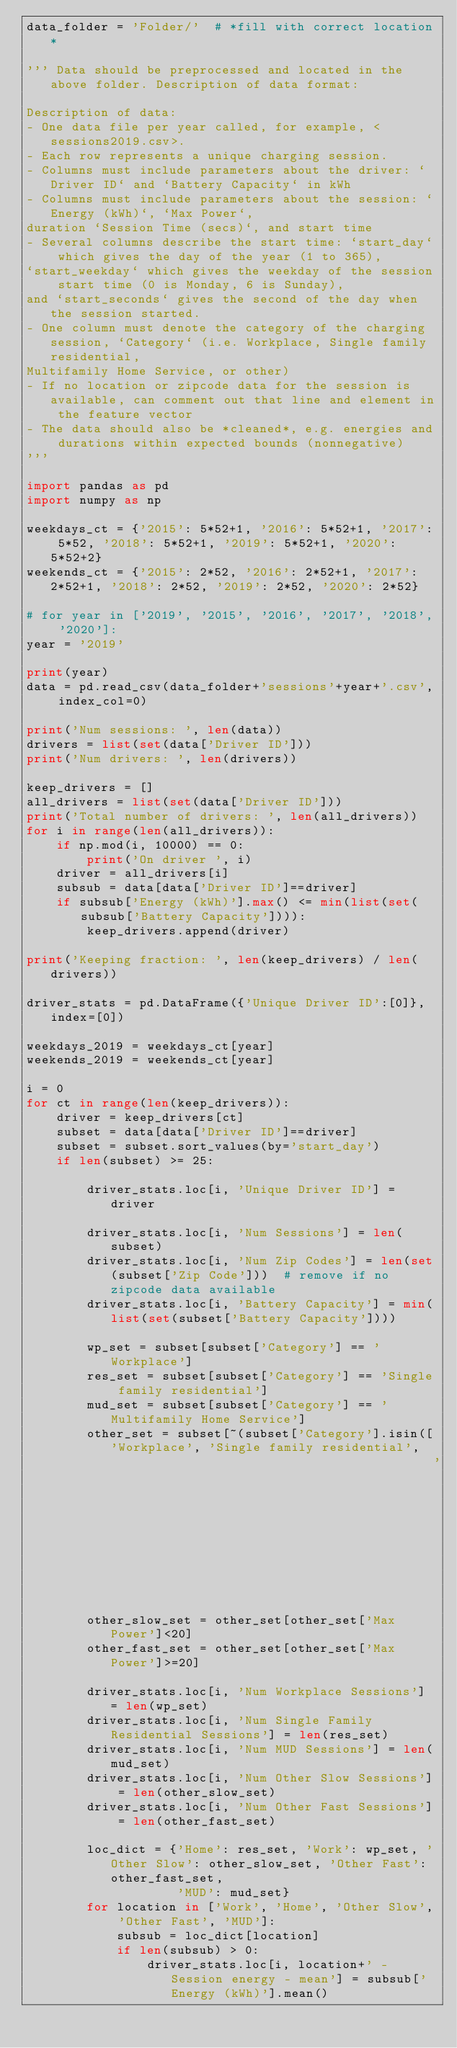Convert code to text. <code><loc_0><loc_0><loc_500><loc_500><_Python_>data_folder = 'Folder/'  # *fill with correct location*

''' Data should be preprocessed and located in the above folder. Description of data format:

Description of data: 
- One data file per year called, for example, <sessions2019.csv>. 
- Each row represents a unique charging session.
- Columns must include parameters about the driver: `Driver ID` and `Battery Capacity` in kWh
- Columns must include parameters about the session: `Energy (kWh)`, `Max Power`, 
duration `Session Time (secs)`, and start time
- Several columns describe the start time: `start_day` which gives the day of the year (1 to 365), 
`start_weekday` which gives the weekday of the session start time (0 is Monday, 6 is Sunday),
and `start_seconds` gives the second of the day when the session started.
- One column must denote the category of the charging session, `Category` (i.e. Workplace, Single family residential, 
Multifamily Home Service, or other)
- If no location or zipcode data for the session is available, can comment out that line and element in the feature vector
- The data should also be *cleaned*, e.g. energies and durations within expected bounds (nonnegative)
'''

import pandas as pd
import numpy as np

weekdays_ct = {'2015': 5*52+1, '2016': 5*52+1, '2017': 5*52, '2018': 5*52+1, '2019': 5*52+1, '2020': 5*52+2}
weekends_ct = {'2015': 2*52, '2016': 2*52+1, '2017': 2*52+1, '2018': 2*52, '2019': 2*52, '2020': 2*52}

# for year in ['2019', '2015', '2016', '2017', '2018', '2020']:
year = '2019'

print(year)
data = pd.read_csv(data_folder+'sessions'+year+'.csv', index_col=0)

print('Num sessions: ', len(data))
drivers = list(set(data['Driver ID']))
print('Num drivers: ', len(drivers))

keep_drivers = []
all_drivers = list(set(data['Driver ID']))
print('Total number of drivers: ', len(all_drivers))
for i in range(len(all_drivers)):
    if np.mod(i, 10000) == 0:
        print('On driver ', i)
    driver = all_drivers[i]
    subsub = data[data['Driver ID']==driver]
    if subsub['Energy (kWh)'].max() <= min(list(set(subsub['Battery Capacity']))):
        keep_drivers.append(driver)

print('Keeping fraction: ', len(keep_drivers) / len(drivers))

driver_stats = pd.DataFrame({'Unique Driver ID':[0]}, index=[0])

weekdays_2019 = weekdays_ct[year]
weekends_2019 = weekends_ct[year]

i = 0
for ct in range(len(keep_drivers)):
    driver = keep_drivers[ct]
    subset = data[data['Driver ID']==driver]
    subset = subset.sort_values(by='start_day')
    if len(subset) >= 25:

        driver_stats.loc[i, 'Unique Driver ID'] = driver

        driver_stats.loc[i, 'Num Sessions'] = len(subset)
        driver_stats.loc[i, 'Num Zip Codes'] = len(set(subset['Zip Code']))  # remove if no zipcode data available
        driver_stats.loc[i, 'Battery Capacity'] = min(list(set(subset['Battery Capacity'])))

        wp_set = subset[subset['Category'] == 'Workplace']
        res_set = subset[subset['Category'] == 'Single family residential']
        mud_set = subset[subset['Category'] == 'Multifamily Home Service']
        other_set = subset[~(subset['Category'].isin(['Workplace', 'Single family residential',
                                                      'Multifamily Home Service']))]
        other_slow_set = other_set[other_set['Max Power']<20]
        other_fast_set = other_set[other_set['Max Power']>=20]

        driver_stats.loc[i, 'Num Workplace Sessions'] = len(wp_set)
        driver_stats.loc[i, 'Num Single Family Residential Sessions'] = len(res_set)
        driver_stats.loc[i, 'Num MUD Sessions'] = len(mud_set)
        driver_stats.loc[i, 'Num Other Slow Sessions'] = len(other_slow_set)
        driver_stats.loc[i, 'Num Other Fast Sessions'] = len(other_fast_set)

        loc_dict = {'Home': res_set, 'Work': wp_set, 'Other Slow': other_slow_set, 'Other Fast': other_fast_set,
                    'MUD': mud_set}
        for location in ['Work', 'Home', 'Other Slow', 'Other Fast', 'MUD']:
            subsub = loc_dict[location]
            if len(subsub) > 0:
                driver_stats.loc[i, location+' - Session energy - mean'] = subsub['Energy (kWh)'].mean()</code> 